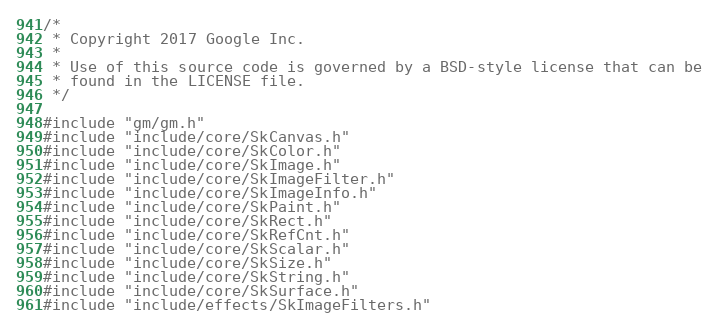<code> <loc_0><loc_0><loc_500><loc_500><_C++_>/*
 * Copyright 2017 Google Inc.
 *
 * Use of this source code is governed by a BSD-style license that can be
 * found in the LICENSE file.
 */

#include "gm/gm.h"
#include "include/core/SkCanvas.h"
#include "include/core/SkColor.h"
#include "include/core/SkImage.h"
#include "include/core/SkImageFilter.h"
#include "include/core/SkImageInfo.h"
#include "include/core/SkPaint.h"
#include "include/core/SkRect.h"
#include "include/core/SkRefCnt.h"
#include "include/core/SkScalar.h"
#include "include/core/SkSize.h"
#include "include/core/SkString.h"
#include "include/core/SkSurface.h"
#include "include/effects/SkImageFilters.h"</code> 